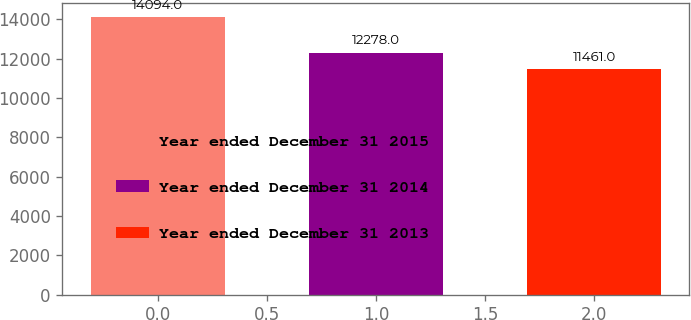Convert chart. <chart><loc_0><loc_0><loc_500><loc_500><bar_chart><fcel>Year ended December 31 2015<fcel>Year ended December 31 2014<fcel>Year ended December 31 2013<nl><fcel>14094<fcel>12278<fcel>11461<nl></chart> 